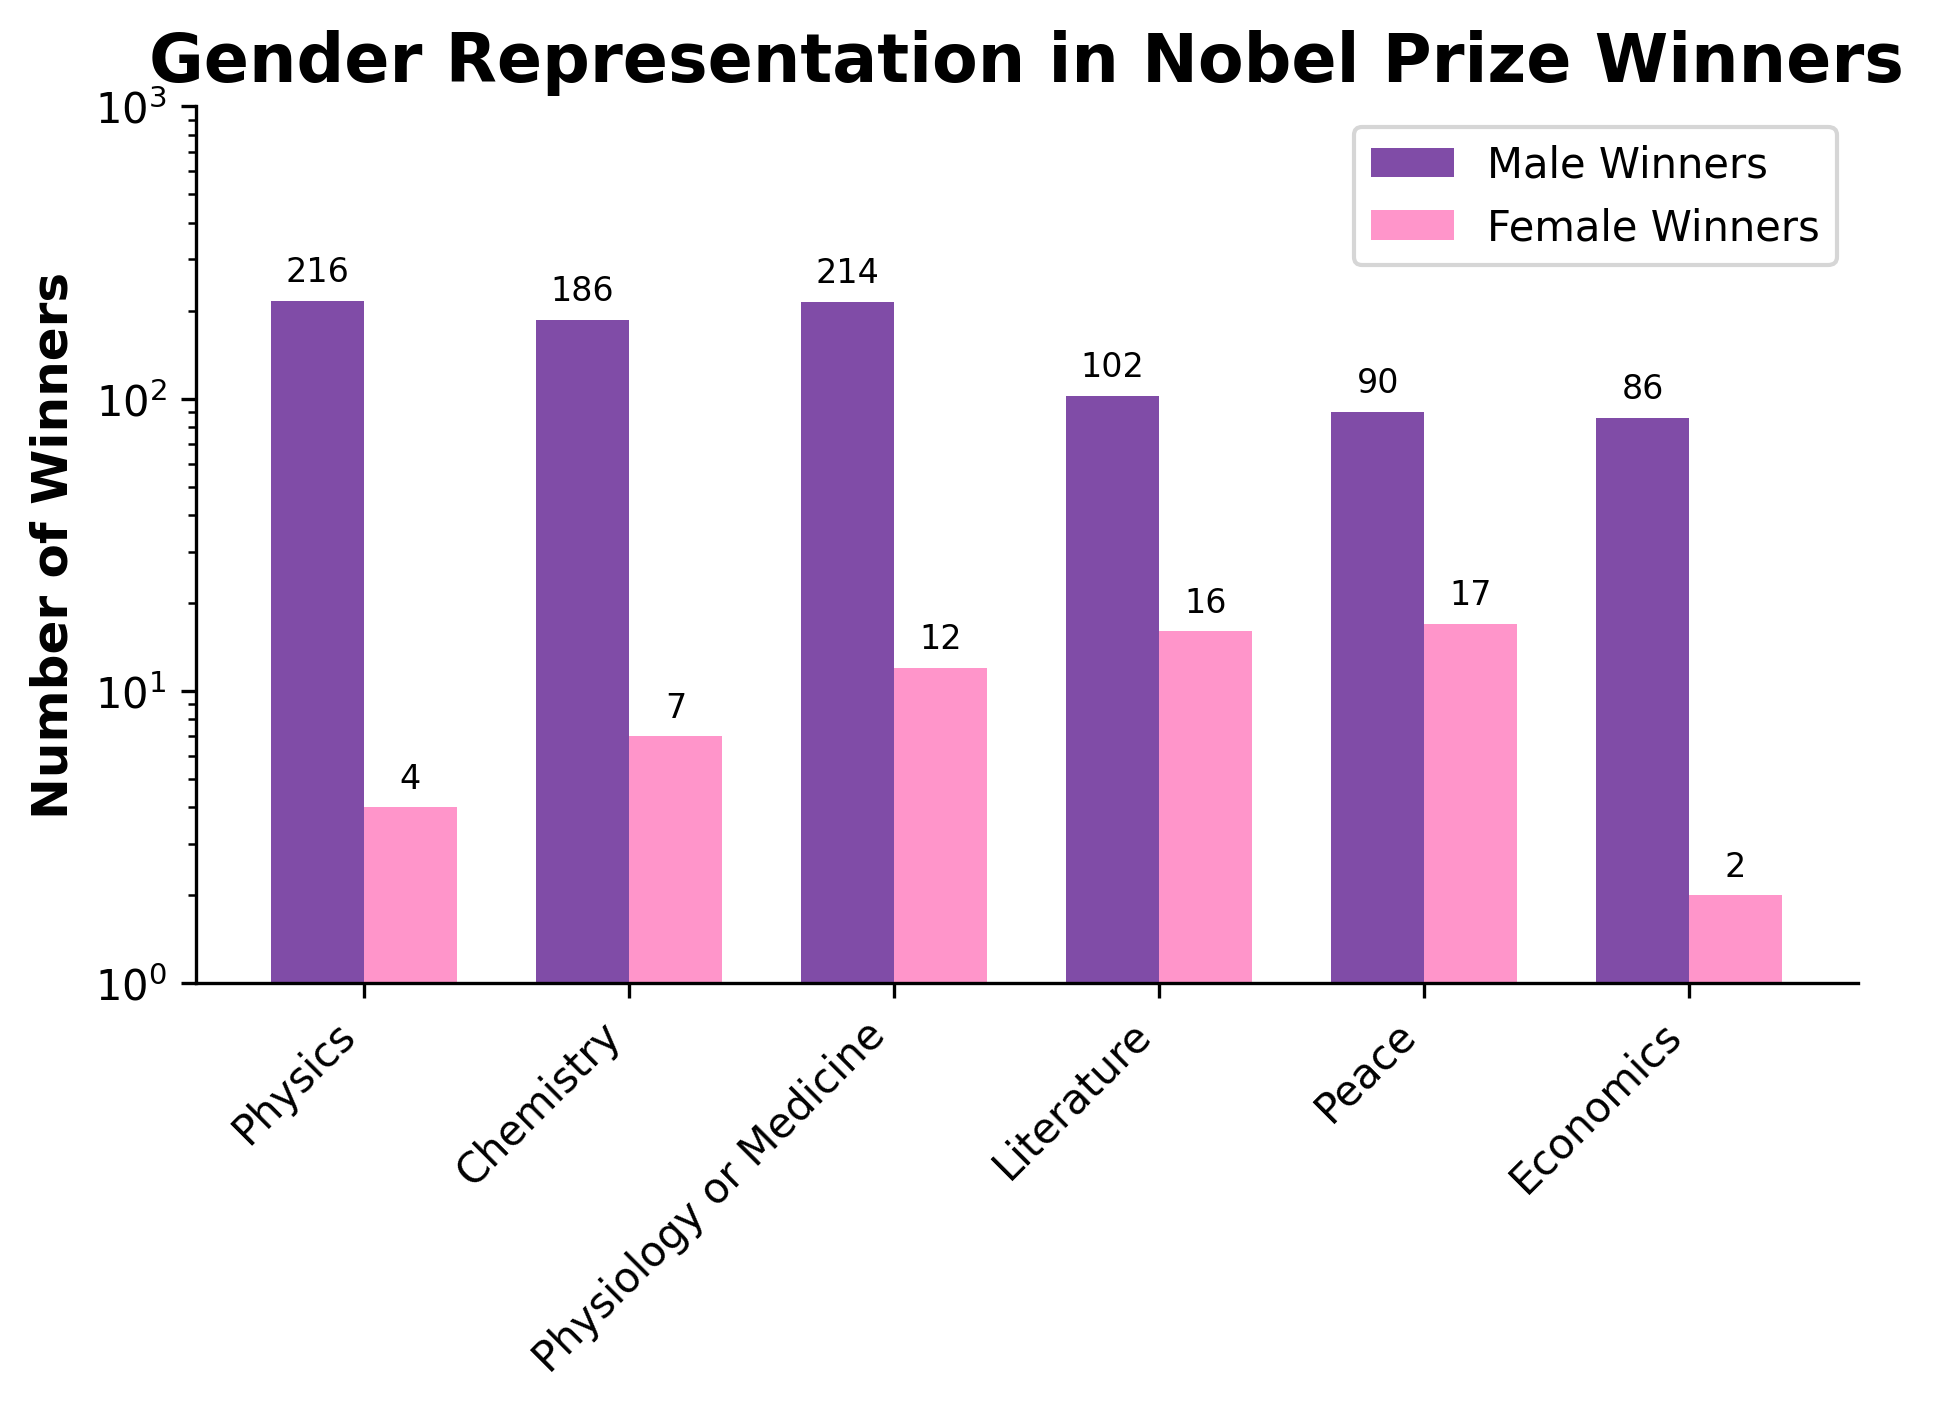What field has the highest number of male Nobel Prize winners? By looking at the heights of the purple bars representing male winners, we can see that the field with the highest bar is Physics.
Answer: Physics Which field has the lowest number of female Nobel Prize winners? By examining the pink bars representing female winners, Economics has the smallest bar indicating the lowest number of female winners.
Answer: Economics How many more male winners than female winners are there in Chemistry? The number of male winners in Chemistry is 186, and the number of female winners is 7. The difference is 186 - 7 = 179.
Answer: 179 Which field has the closest number of male and female Nobel Prize winners? By comparing the heights of the purple and pink bars, the field with the closest values is Peace, with 90 male winners and 17 female winners (a difference of 73).
Answer: Peace How does the number of female winners in Literature compare to the number of female winners in Medicine? The pink bar representing female winners in Literature is about 16, whereas in Medicine it is 12. Since 16 is greater than 12, Literature has more female winners.
Answer: Literature In which fields do female winners exceed 10? The pink bars representing female winners exceed 10 in the fields of Physiology or Medicine (12), Literature (16), and Peace (17).
Answer: Physiology or Medicine, Literature, Peace What is the total number of male and female winners in Economics? The number of male winners in Economics is 86 and female winners is 2. Their total is 86 + 2 = 88.
Answer: 88 Which field has the least gender disparity among winners? Comparing the gap between purple and pink bars, Peace has the least disparity with a difference of 73 winners.
Answer: Peace How many more male winners are there in Physics compared to Literature? The number of male winners in Physics is 216 and in Literature is 102. The difference is 216 - 102 = 114.
Answer: 114 Calculate the average number of female Nobel Prize winners across all fields. Sum the number of female winners in all fields: 4 (Physics) + 7 (Chemistry) + 12 (Physiology or Medicine) + 16 (Literature) + 17 (Peace) + 2 (Economics) = 58. There are 6 fields, so the average is 58 / 6 ≈ 9.67.
Answer: 9.67 